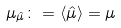<formula> <loc_0><loc_0><loc_500><loc_500>\mu _ { \hat { \mu } } \colon = \langle \hat { \mu } \rangle = \mu</formula> 